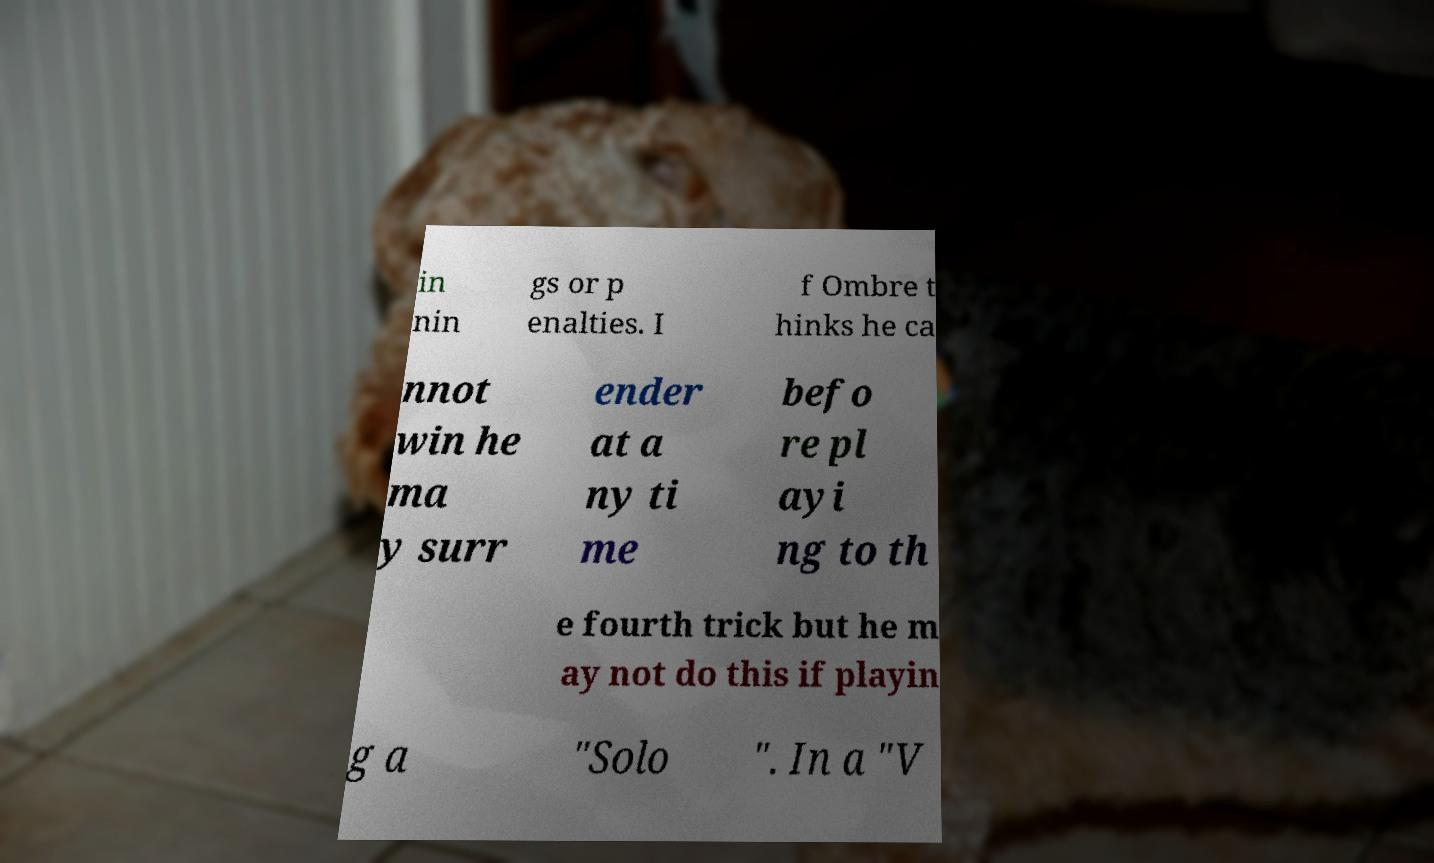Could you assist in decoding the text presented in this image and type it out clearly? in nin gs or p enalties. I f Ombre t hinks he ca nnot win he ma y surr ender at a ny ti me befo re pl ayi ng to th e fourth trick but he m ay not do this if playin g a "Solo ". In a "V 